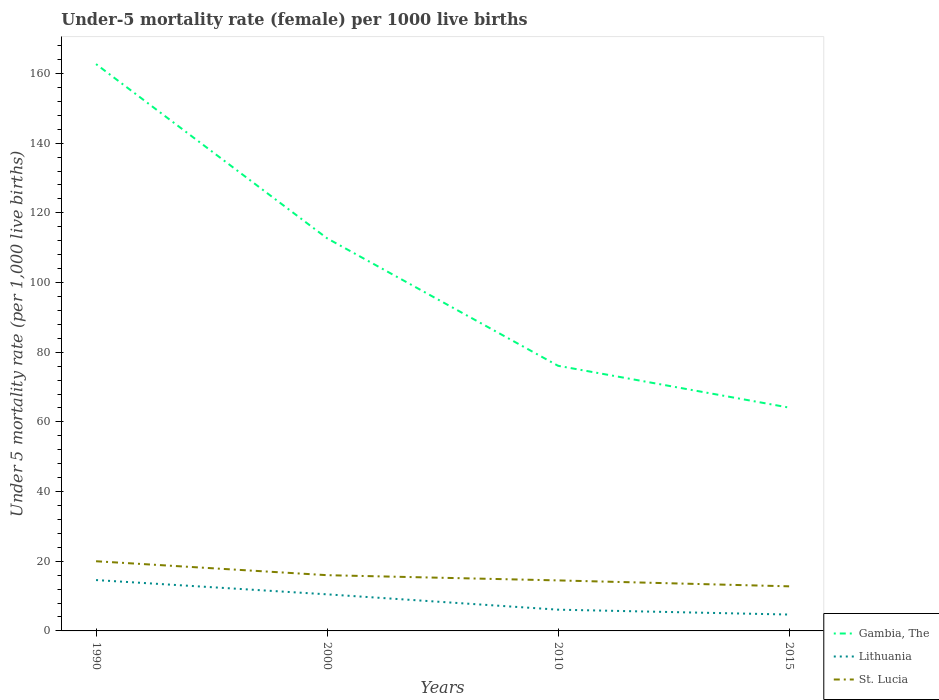Is the number of lines equal to the number of legend labels?
Ensure brevity in your answer.  Yes. Across all years, what is the maximum under-five mortality rate in Gambia, The?
Your response must be concise. 64.1. In which year was the under-five mortality rate in Gambia, The maximum?
Give a very brief answer. 2015. What is the total under-five mortality rate in St. Lucia in the graph?
Provide a succinct answer. 7.2. What is the difference between the highest and the second highest under-five mortality rate in Lithuania?
Keep it short and to the point. 9.9. What is the difference between the highest and the lowest under-five mortality rate in St. Lucia?
Offer a very short reply. 2. Is the under-five mortality rate in Gambia, The strictly greater than the under-five mortality rate in St. Lucia over the years?
Ensure brevity in your answer.  No. What is the difference between two consecutive major ticks on the Y-axis?
Make the answer very short. 20. Does the graph contain any zero values?
Ensure brevity in your answer.  No. How are the legend labels stacked?
Offer a very short reply. Vertical. What is the title of the graph?
Provide a succinct answer. Under-5 mortality rate (female) per 1000 live births. Does "Indonesia" appear as one of the legend labels in the graph?
Ensure brevity in your answer.  No. What is the label or title of the X-axis?
Keep it short and to the point. Years. What is the label or title of the Y-axis?
Your answer should be compact. Under 5 mortality rate (per 1,0 live births). What is the Under 5 mortality rate (per 1,000 live births) in Gambia, The in 1990?
Provide a succinct answer. 162.7. What is the Under 5 mortality rate (per 1,000 live births) in St. Lucia in 1990?
Make the answer very short. 20. What is the Under 5 mortality rate (per 1,000 live births) of Gambia, The in 2000?
Ensure brevity in your answer.  112.7. What is the Under 5 mortality rate (per 1,000 live births) of Lithuania in 2000?
Keep it short and to the point. 10.5. What is the Under 5 mortality rate (per 1,000 live births) in Gambia, The in 2010?
Ensure brevity in your answer.  76.1. What is the Under 5 mortality rate (per 1,000 live births) of Gambia, The in 2015?
Provide a short and direct response. 64.1. What is the Under 5 mortality rate (per 1,000 live births) in Lithuania in 2015?
Ensure brevity in your answer.  4.7. What is the Under 5 mortality rate (per 1,000 live births) in St. Lucia in 2015?
Keep it short and to the point. 12.8. Across all years, what is the maximum Under 5 mortality rate (per 1,000 live births) of Gambia, The?
Your response must be concise. 162.7. Across all years, what is the maximum Under 5 mortality rate (per 1,000 live births) in St. Lucia?
Keep it short and to the point. 20. Across all years, what is the minimum Under 5 mortality rate (per 1,000 live births) in Gambia, The?
Your answer should be very brief. 64.1. What is the total Under 5 mortality rate (per 1,000 live births) in Gambia, The in the graph?
Provide a short and direct response. 415.6. What is the total Under 5 mortality rate (per 1,000 live births) of Lithuania in the graph?
Your answer should be compact. 35.9. What is the total Under 5 mortality rate (per 1,000 live births) of St. Lucia in the graph?
Give a very brief answer. 63.3. What is the difference between the Under 5 mortality rate (per 1,000 live births) in Gambia, The in 1990 and that in 2000?
Provide a succinct answer. 50. What is the difference between the Under 5 mortality rate (per 1,000 live births) of St. Lucia in 1990 and that in 2000?
Your response must be concise. 4. What is the difference between the Under 5 mortality rate (per 1,000 live births) in Gambia, The in 1990 and that in 2010?
Your answer should be very brief. 86.6. What is the difference between the Under 5 mortality rate (per 1,000 live births) in Lithuania in 1990 and that in 2010?
Your answer should be compact. 8.5. What is the difference between the Under 5 mortality rate (per 1,000 live births) in Gambia, The in 1990 and that in 2015?
Provide a succinct answer. 98.6. What is the difference between the Under 5 mortality rate (per 1,000 live births) of St. Lucia in 1990 and that in 2015?
Give a very brief answer. 7.2. What is the difference between the Under 5 mortality rate (per 1,000 live births) of Gambia, The in 2000 and that in 2010?
Keep it short and to the point. 36.6. What is the difference between the Under 5 mortality rate (per 1,000 live births) in Gambia, The in 2000 and that in 2015?
Keep it short and to the point. 48.6. What is the difference between the Under 5 mortality rate (per 1,000 live births) of Lithuania in 2000 and that in 2015?
Your answer should be very brief. 5.8. What is the difference between the Under 5 mortality rate (per 1,000 live births) of Gambia, The in 2010 and that in 2015?
Provide a short and direct response. 12. What is the difference between the Under 5 mortality rate (per 1,000 live births) of St. Lucia in 2010 and that in 2015?
Your answer should be compact. 1.7. What is the difference between the Under 5 mortality rate (per 1,000 live births) in Gambia, The in 1990 and the Under 5 mortality rate (per 1,000 live births) in Lithuania in 2000?
Ensure brevity in your answer.  152.2. What is the difference between the Under 5 mortality rate (per 1,000 live births) in Gambia, The in 1990 and the Under 5 mortality rate (per 1,000 live births) in St. Lucia in 2000?
Give a very brief answer. 146.7. What is the difference between the Under 5 mortality rate (per 1,000 live births) of Gambia, The in 1990 and the Under 5 mortality rate (per 1,000 live births) of Lithuania in 2010?
Offer a very short reply. 156.6. What is the difference between the Under 5 mortality rate (per 1,000 live births) in Gambia, The in 1990 and the Under 5 mortality rate (per 1,000 live births) in St. Lucia in 2010?
Offer a terse response. 148.2. What is the difference between the Under 5 mortality rate (per 1,000 live births) in Gambia, The in 1990 and the Under 5 mortality rate (per 1,000 live births) in Lithuania in 2015?
Keep it short and to the point. 158. What is the difference between the Under 5 mortality rate (per 1,000 live births) in Gambia, The in 1990 and the Under 5 mortality rate (per 1,000 live births) in St. Lucia in 2015?
Provide a short and direct response. 149.9. What is the difference between the Under 5 mortality rate (per 1,000 live births) in Lithuania in 1990 and the Under 5 mortality rate (per 1,000 live births) in St. Lucia in 2015?
Provide a succinct answer. 1.8. What is the difference between the Under 5 mortality rate (per 1,000 live births) in Gambia, The in 2000 and the Under 5 mortality rate (per 1,000 live births) in Lithuania in 2010?
Keep it short and to the point. 106.6. What is the difference between the Under 5 mortality rate (per 1,000 live births) of Gambia, The in 2000 and the Under 5 mortality rate (per 1,000 live births) of St. Lucia in 2010?
Ensure brevity in your answer.  98.2. What is the difference between the Under 5 mortality rate (per 1,000 live births) in Gambia, The in 2000 and the Under 5 mortality rate (per 1,000 live births) in Lithuania in 2015?
Your answer should be compact. 108. What is the difference between the Under 5 mortality rate (per 1,000 live births) of Gambia, The in 2000 and the Under 5 mortality rate (per 1,000 live births) of St. Lucia in 2015?
Keep it short and to the point. 99.9. What is the difference between the Under 5 mortality rate (per 1,000 live births) of Gambia, The in 2010 and the Under 5 mortality rate (per 1,000 live births) of Lithuania in 2015?
Give a very brief answer. 71.4. What is the difference between the Under 5 mortality rate (per 1,000 live births) of Gambia, The in 2010 and the Under 5 mortality rate (per 1,000 live births) of St. Lucia in 2015?
Keep it short and to the point. 63.3. What is the average Under 5 mortality rate (per 1,000 live births) of Gambia, The per year?
Offer a very short reply. 103.9. What is the average Under 5 mortality rate (per 1,000 live births) of Lithuania per year?
Your answer should be very brief. 8.97. What is the average Under 5 mortality rate (per 1,000 live births) in St. Lucia per year?
Keep it short and to the point. 15.82. In the year 1990, what is the difference between the Under 5 mortality rate (per 1,000 live births) of Gambia, The and Under 5 mortality rate (per 1,000 live births) of Lithuania?
Your answer should be compact. 148.1. In the year 1990, what is the difference between the Under 5 mortality rate (per 1,000 live births) of Gambia, The and Under 5 mortality rate (per 1,000 live births) of St. Lucia?
Your answer should be compact. 142.7. In the year 1990, what is the difference between the Under 5 mortality rate (per 1,000 live births) in Lithuania and Under 5 mortality rate (per 1,000 live births) in St. Lucia?
Offer a very short reply. -5.4. In the year 2000, what is the difference between the Under 5 mortality rate (per 1,000 live births) in Gambia, The and Under 5 mortality rate (per 1,000 live births) in Lithuania?
Offer a very short reply. 102.2. In the year 2000, what is the difference between the Under 5 mortality rate (per 1,000 live births) in Gambia, The and Under 5 mortality rate (per 1,000 live births) in St. Lucia?
Your answer should be compact. 96.7. In the year 2000, what is the difference between the Under 5 mortality rate (per 1,000 live births) in Lithuania and Under 5 mortality rate (per 1,000 live births) in St. Lucia?
Offer a very short reply. -5.5. In the year 2010, what is the difference between the Under 5 mortality rate (per 1,000 live births) in Gambia, The and Under 5 mortality rate (per 1,000 live births) in Lithuania?
Give a very brief answer. 70. In the year 2010, what is the difference between the Under 5 mortality rate (per 1,000 live births) of Gambia, The and Under 5 mortality rate (per 1,000 live births) of St. Lucia?
Provide a succinct answer. 61.6. In the year 2010, what is the difference between the Under 5 mortality rate (per 1,000 live births) of Lithuania and Under 5 mortality rate (per 1,000 live births) of St. Lucia?
Provide a short and direct response. -8.4. In the year 2015, what is the difference between the Under 5 mortality rate (per 1,000 live births) in Gambia, The and Under 5 mortality rate (per 1,000 live births) in Lithuania?
Provide a succinct answer. 59.4. In the year 2015, what is the difference between the Under 5 mortality rate (per 1,000 live births) in Gambia, The and Under 5 mortality rate (per 1,000 live births) in St. Lucia?
Keep it short and to the point. 51.3. In the year 2015, what is the difference between the Under 5 mortality rate (per 1,000 live births) of Lithuania and Under 5 mortality rate (per 1,000 live births) of St. Lucia?
Offer a terse response. -8.1. What is the ratio of the Under 5 mortality rate (per 1,000 live births) of Gambia, The in 1990 to that in 2000?
Ensure brevity in your answer.  1.44. What is the ratio of the Under 5 mortality rate (per 1,000 live births) in Lithuania in 1990 to that in 2000?
Ensure brevity in your answer.  1.39. What is the ratio of the Under 5 mortality rate (per 1,000 live births) in St. Lucia in 1990 to that in 2000?
Your answer should be compact. 1.25. What is the ratio of the Under 5 mortality rate (per 1,000 live births) in Gambia, The in 1990 to that in 2010?
Provide a succinct answer. 2.14. What is the ratio of the Under 5 mortality rate (per 1,000 live births) in Lithuania in 1990 to that in 2010?
Provide a short and direct response. 2.39. What is the ratio of the Under 5 mortality rate (per 1,000 live births) in St. Lucia in 1990 to that in 2010?
Provide a succinct answer. 1.38. What is the ratio of the Under 5 mortality rate (per 1,000 live births) in Gambia, The in 1990 to that in 2015?
Ensure brevity in your answer.  2.54. What is the ratio of the Under 5 mortality rate (per 1,000 live births) in Lithuania in 1990 to that in 2015?
Offer a terse response. 3.11. What is the ratio of the Under 5 mortality rate (per 1,000 live births) of St. Lucia in 1990 to that in 2015?
Your answer should be very brief. 1.56. What is the ratio of the Under 5 mortality rate (per 1,000 live births) of Gambia, The in 2000 to that in 2010?
Provide a short and direct response. 1.48. What is the ratio of the Under 5 mortality rate (per 1,000 live births) of Lithuania in 2000 to that in 2010?
Ensure brevity in your answer.  1.72. What is the ratio of the Under 5 mortality rate (per 1,000 live births) in St. Lucia in 2000 to that in 2010?
Keep it short and to the point. 1.1. What is the ratio of the Under 5 mortality rate (per 1,000 live births) of Gambia, The in 2000 to that in 2015?
Ensure brevity in your answer.  1.76. What is the ratio of the Under 5 mortality rate (per 1,000 live births) of Lithuania in 2000 to that in 2015?
Provide a succinct answer. 2.23. What is the ratio of the Under 5 mortality rate (per 1,000 live births) in St. Lucia in 2000 to that in 2015?
Your answer should be very brief. 1.25. What is the ratio of the Under 5 mortality rate (per 1,000 live births) of Gambia, The in 2010 to that in 2015?
Your answer should be compact. 1.19. What is the ratio of the Under 5 mortality rate (per 1,000 live births) of Lithuania in 2010 to that in 2015?
Ensure brevity in your answer.  1.3. What is the ratio of the Under 5 mortality rate (per 1,000 live births) of St. Lucia in 2010 to that in 2015?
Your response must be concise. 1.13. What is the difference between the highest and the second highest Under 5 mortality rate (per 1,000 live births) of Gambia, The?
Make the answer very short. 50. What is the difference between the highest and the second highest Under 5 mortality rate (per 1,000 live births) of Lithuania?
Your answer should be compact. 4.1. What is the difference between the highest and the lowest Under 5 mortality rate (per 1,000 live births) in Gambia, The?
Ensure brevity in your answer.  98.6. 